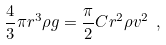Convert formula to latex. <formula><loc_0><loc_0><loc_500><loc_500>\frac { 4 } { 3 } \pi r ^ { 3 } \rho g = \frac { \pi } { 2 } C r ^ { 2 } \rho v ^ { 2 } \ ,</formula> 